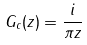<formula> <loc_0><loc_0><loc_500><loc_500>G _ { c } ( z ) = \frac { i } { \pi z }</formula> 